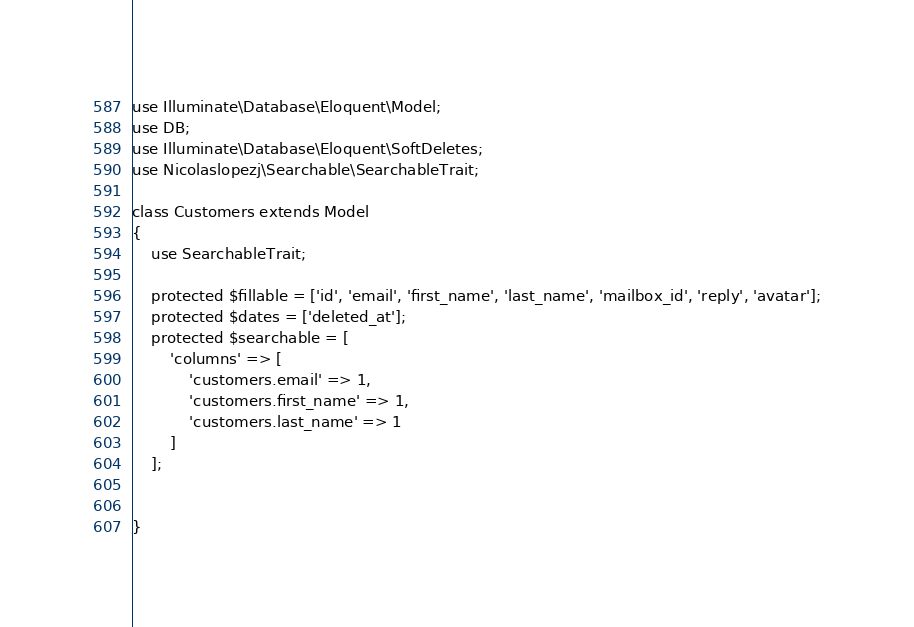Convert code to text. <code><loc_0><loc_0><loc_500><loc_500><_PHP_>use Illuminate\Database\Eloquent\Model;
use DB;
use Illuminate\Database\Eloquent\SoftDeletes;
use Nicolaslopezj\Searchable\SearchableTrait;

class Customers extends Model
{
    use SearchableTrait;

    protected $fillable = ['id', 'email', 'first_name', 'last_name', 'mailbox_id', 'reply', 'avatar'];
    protected $dates = ['deleted_at'];
    protected $searchable = [
        'columns' => [
            'customers.email' => 1,
            'customers.first_name' => 1,
            'customers.last_name' => 1
        ]
    ];


}
</code> 